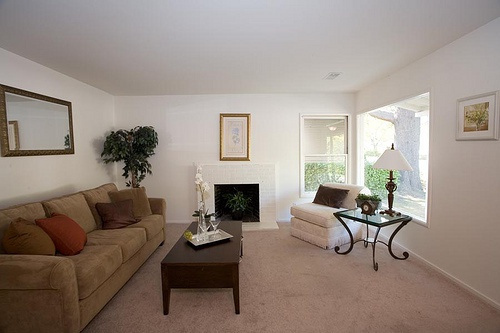Describe the objects in this image and their specific colors. I can see couch in gray, maroon, and black tones, dining table in gray, black, maroon, and darkgray tones, chair in gray, darkgray, and black tones, potted plant in gray, black, and darkgray tones, and potted plant in gray, black, and darkgreen tones in this image. 